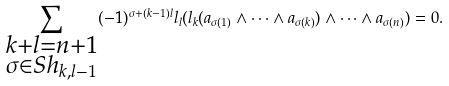Convert formula to latex. <formula><loc_0><loc_0><loc_500><loc_500>\sum _ { \substack { k + l = n + 1 \\ \sigma \in S h _ { k , l - 1 } } } ( - 1 ) ^ { \sigma + ( k - 1 ) l } l _ { l } ( l _ { k } ( a _ { \sigma ( 1 ) } \wedge \dots \wedge a _ { \sigma ( k ) } ) \wedge \dots \wedge a _ { \sigma ( n ) } ) = 0 .</formula> 